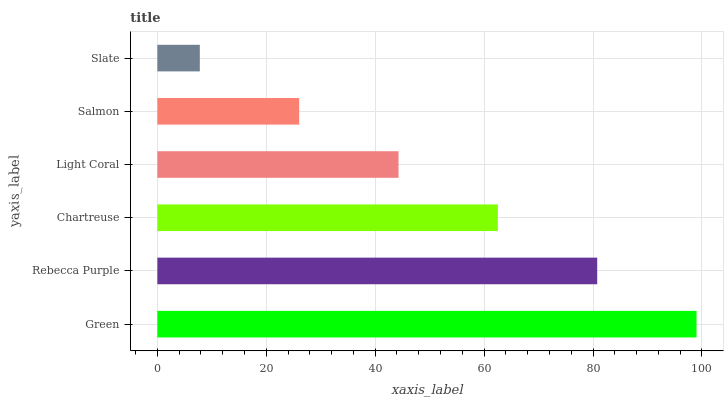Is Slate the minimum?
Answer yes or no. Yes. Is Green the maximum?
Answer yes or no. Yes. Is Rebecca Purple the minimum?
Answer yes or no. No. Is Rebecca Purple the maximum?
Answer yes or no. No. Is Green greater than Rebecca Purple?
Answer yes or no. Yes. Is Rebecca Purple less than Green?
Answer yes or no. Yes. Is Rebecca Purple greater than Green?
Answer yes or no. No. Is Green less than Rebecca Purple?
Answer yes or no. No. Is Chartreuse the high median?
Answer yes or no. Yes. Is Light Coral the low median?
Answer yes or no. Yes. Is Slate the high median?
Answer yes or no. No. Is Salmon the low median?
Answer yes or no. No. 